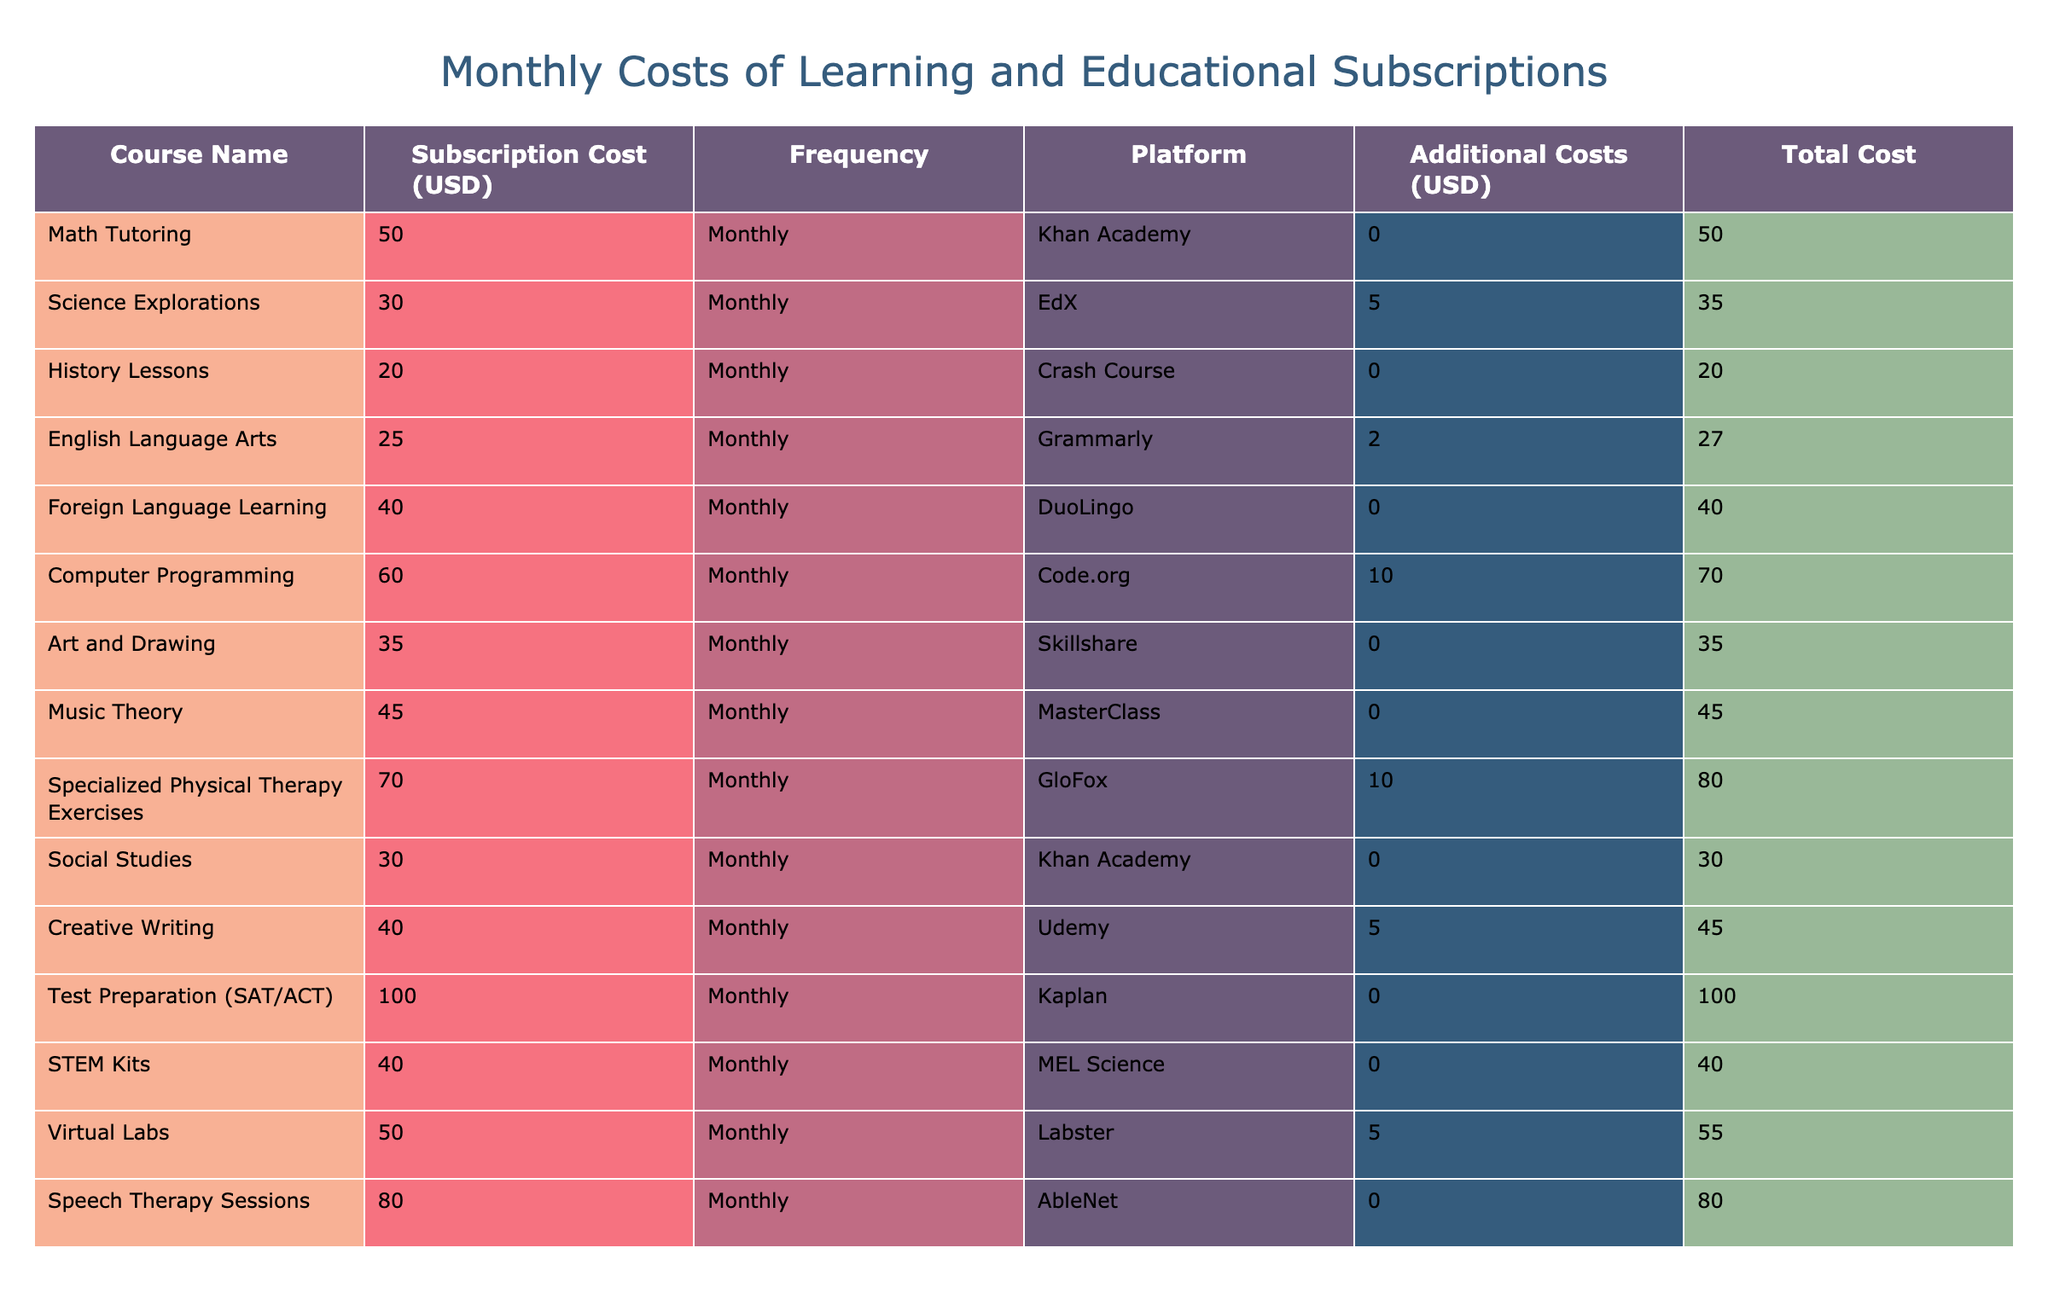What is the subscription cost of Music Theory? The table lists the subscription costs for each course, and looking for "Music Theory" in the Course Name column, I find it listed as 45.
Answer: 45 Which course has the highest total cost, including additional costs? To find the highest total cost, I need to look at the Total Cost column. I can see Test Preparation (SAT/ACT) has the highest subscription cost at 100, and no additional costs, resulting in a total cost of 100.
Answer: 100 Are there any courses with no additional costs? I can check the Additional Costs column for any entries that show 0. After reviewing, I find several courses with no additional costs, such as Math Tutoring, History Lessons, Foreign Language Learning, and more.
Answer: Yes What is the average subscription cost of the courses listed? To calculate the average, I sum up all the subscription costs: 50 + 30 + 20 + 25 + 40 + 60 + 35 + 45 + 70 + 30 + 40 + 100 + 40 + 50 + 80 =  650. There are 15 courses, so the average cost is 650 divided by 15, which equals about 43.33.
Answer: 43.33 How much more does Specialized Physical Therapy Exercises cost compared to English Language Arts? I start by checking the subscription costs: Specialized Physical Therapy Exercises costs 70, while English Language Arts costs 25. Subtracting 25 from 70 gives me 45.
Answer: 45 What is the total amount spent on all courses, including additional costs? First, I calculate the total cost for each course, then sum those up. The total costs for each course are: 50 + 35 + 20 + 27 + 40 + 70 + 35 + 45 + 80 + 30 + 45 + 105 + 40 + 55 + 80 =  761. I confirm these values in the Total Cost column.
Answer: 761 Is the total cost of Creative Writing greater than the total cost of Science Explorations? Looking at the Total Cost column, Creative Writing is 45 and Science Explorations is 35. Comparing these two values, 45 is greater than 35.
Answer: Yes Which course combination yields the least total cost when considering additional costs? I analyze the combinations of courses, focusing on their total costs. The two cheapest total costs are Math Tutoring (50) and History Lessons (20). Their combined total cost is 70, which is lower than any other combination of courses.
Answer: Math Tutoring and History Lessons yield 70 